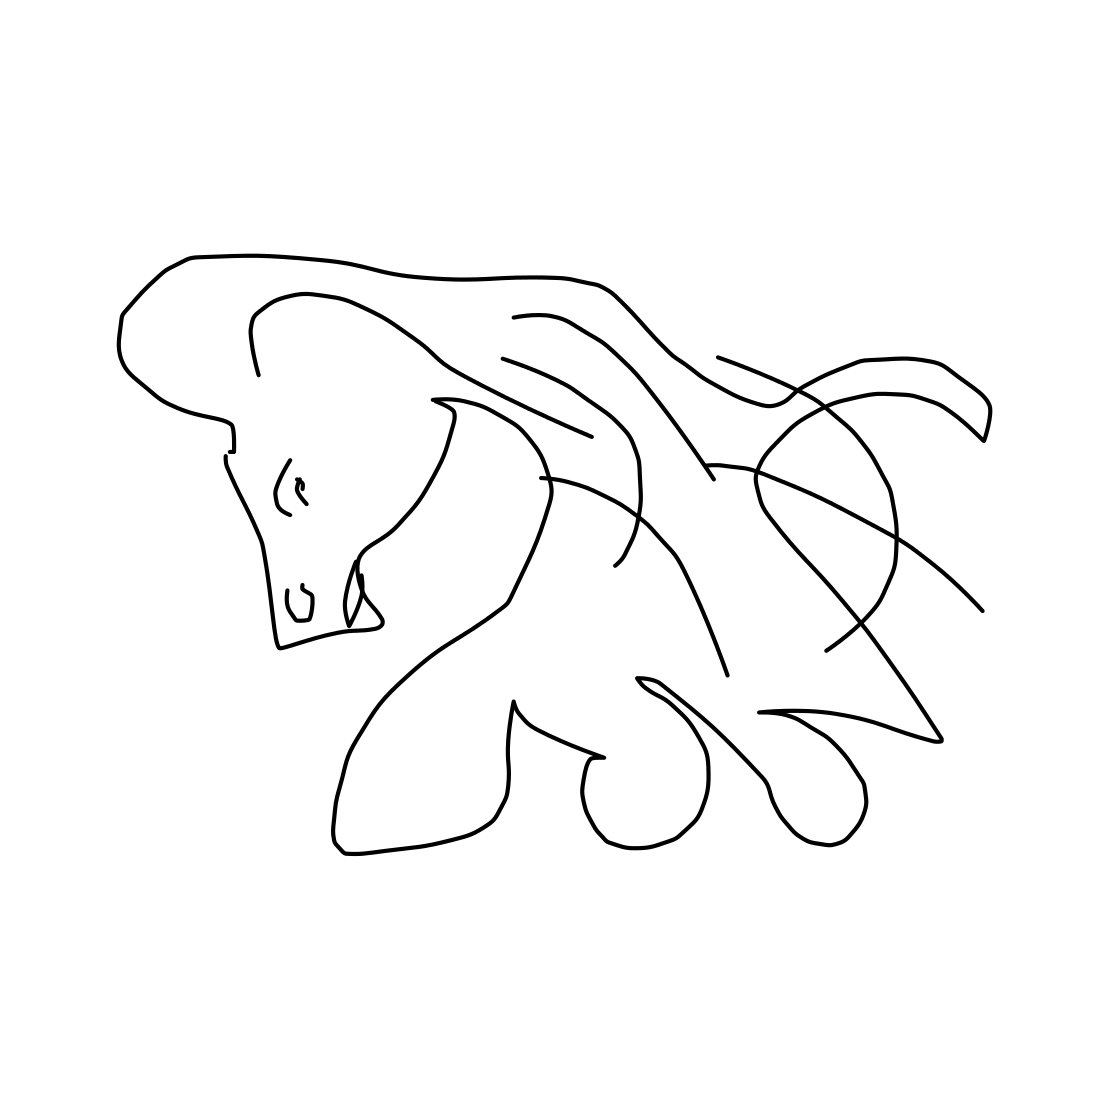Where could an artwork like this be displayed? Artwork of this style would be well-suited to a contemporary art gallery, or it could serve as a sophisticated decorative piece in a modern home or office setting. It's versatile enough to complement a variety of spaces that appreciate minimalism and modern design. How might different viewers interpret this piece? Interpretations of this piece could vary greatly. Some might see it as a symbol of freedom and elegance, reflecting the nature of the horse itself. Others might interpret the simplicity as commentary on the essence of form, or as an invitation to consider the power of line and shape in art. 